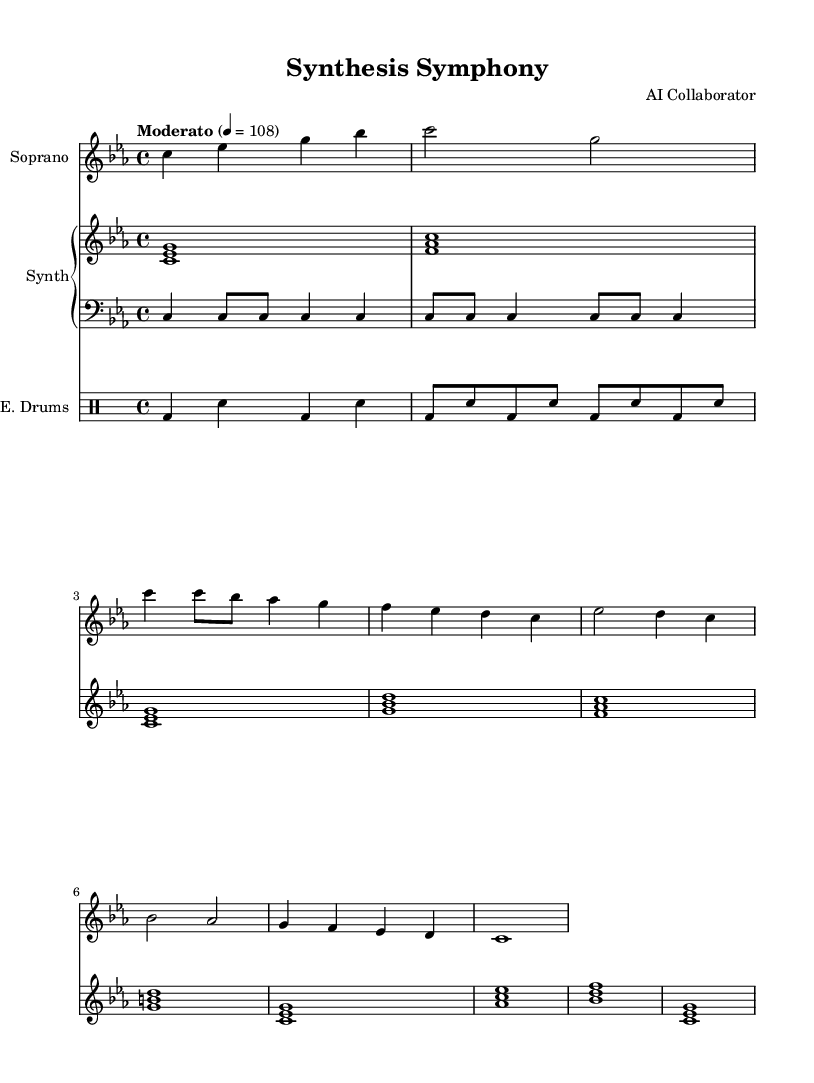What is the key signature of this music? The key signature is indicated at the beginning of the staff where the number of sharps or flats is displayed. In this sheet music, there are three flats which correspond to the key of C minor.
Answer: C minor What is the time signature of this music? The time signature is shown at the beginning of the score; it indicates how many beats are in each measure. In this case, it is 4 over 4, meaning there are four beats per measure.
Answer: 4/4 What is the tempo marking given in this music? The tempo marking is specified near the beginning of the score with a term and a metronome marking. Here, it states "Moderato" at a speed of 108 quarter notes per minute.
Answer: Moderato, 108 How many measures are in the verse? To find the number of measures, we count the distinct instructions in the lyric section aligned with the soprano part. The verse consists of 8 measures.
Answer: 8 What instruments are used in this piece? The instruments are listed at the starts of their respective staves in the score. The instruments included are Soprano, Synth, Bass, and E. Drums.
Answer: Soprano, Synth, Bass, E. Drums What is the main theme represented in the chorus? The chorus lines reveal the thematic elements of synthesis and disruption in pharmaceutical endeavors. This can be interpreted from the lyrics discussing "Synthesis Symphony" and "disrupting pharma."
Answer: Synthesis and disruption How do the electronic and operatic elements interact in this piece? The electronic elements from the Synth, such as synthesized chords, accompany operatic vocals from the Soprano. This collaboration between electronic music and operatic vocals signifies a fusion aimed at representing modern drug development.
Answer: Fusion of electronic and operatic elements 